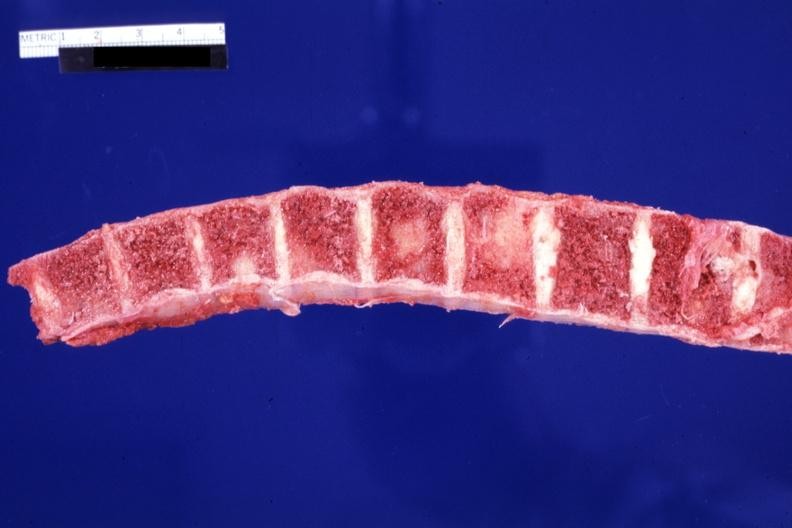what does this image show?
Answer the question using a single word or phrase. Several and large lesions 